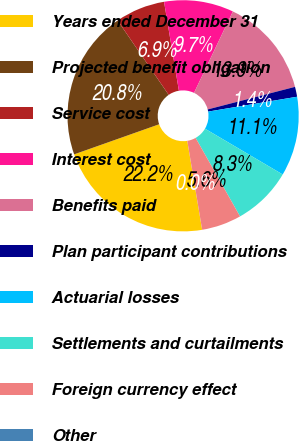Convert chart. <chart><loc_0><loc_0><loc_500><loc_500><pie_chart><fcel>Years ended December 31<fcel>Projected benefit obligation<fcel>Service cost<fcel>Interest cost<fcel>Benefits paid<fcel>Plan participant contributions<fcel>Actuarial losses<fcel>Settlements and curtailments<fcel>Foreign currency effect<fcel>Other<nl><fcel>22.22%<fcel>20.83%<fcel>6.95%<fcel>9.72%<fcel>13.89%<fcel>1.39%<fcel>11.11%<fcel>8.33%<fcel>5.56%<fcel>0.0%<nl></chart> 